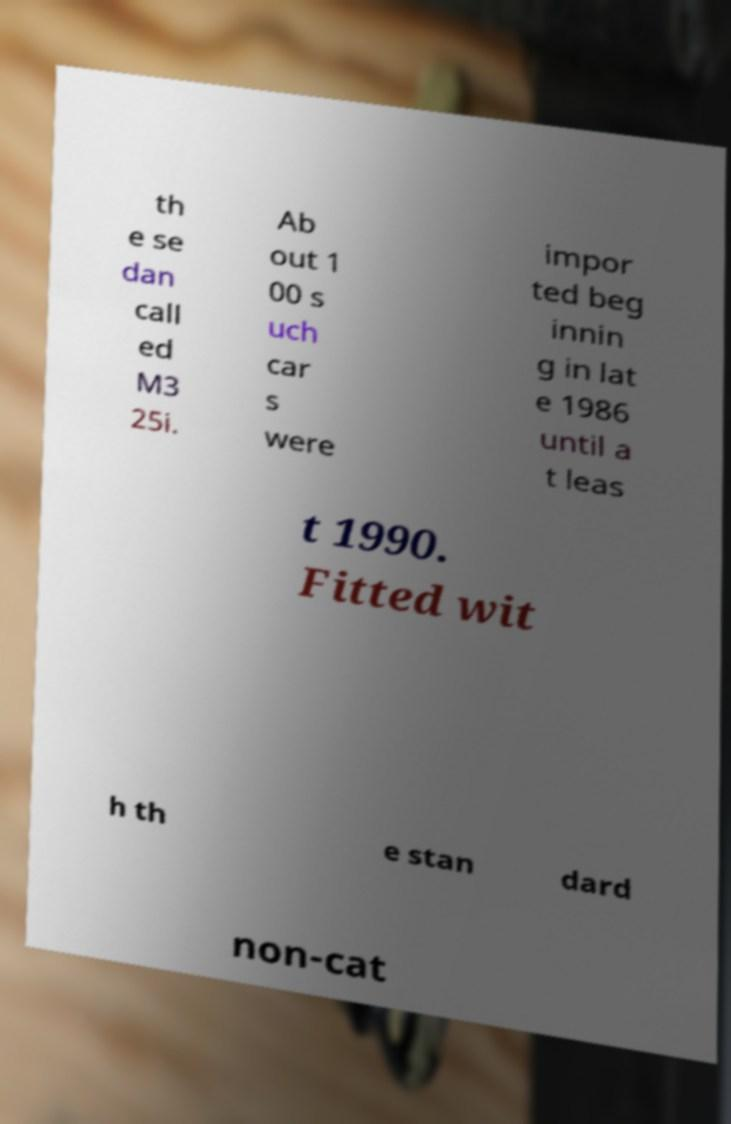There's text embedded in this image that I need extracted. Can you transcribe it verbatim? th e se dan call ed M3 25i. Ab out 1 00 s uch car s were impor ted beg innin g in lat e 1986 until a t leas t 1990. Fitted wit h th e stan dard non-cat 